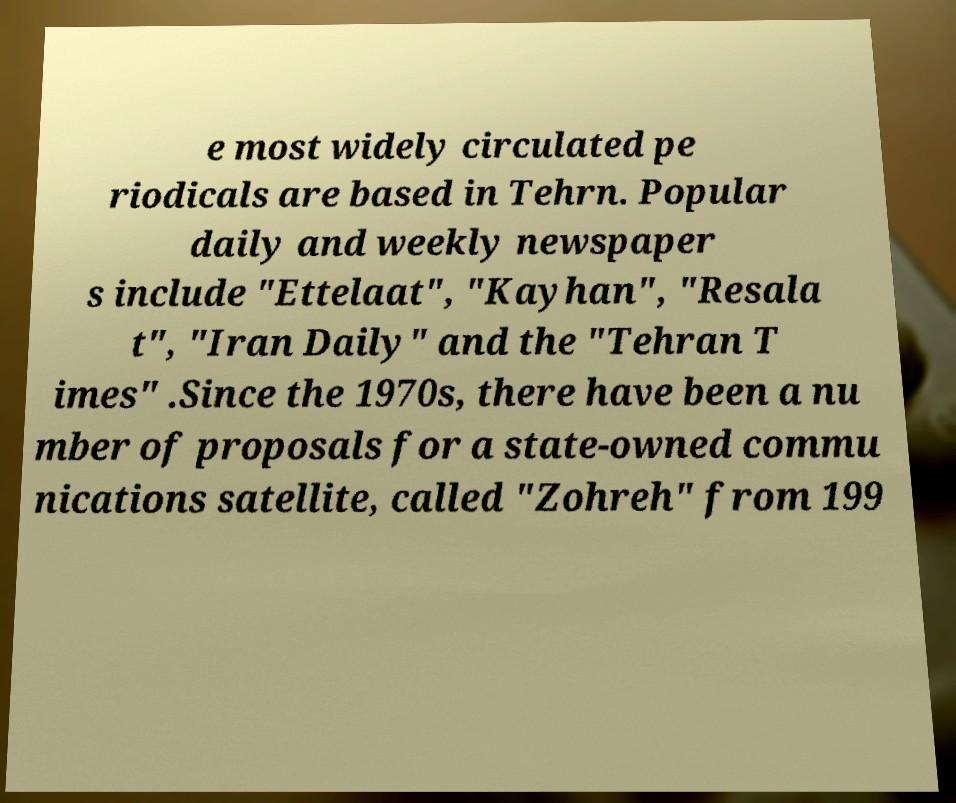Please identify and transcribe the text found in this image. e most widely circulated pe riodicals are based in Tehrn. Popular daily and weekly newspaper s include "Ettelaat", "Kayhan", "Resala t", "Iran Daily" and the "Tehran T imes" .Since the 1970s, there have been a nu mber of proposals for a state-owned commu nications satellite, called "Zohreh" from 199 